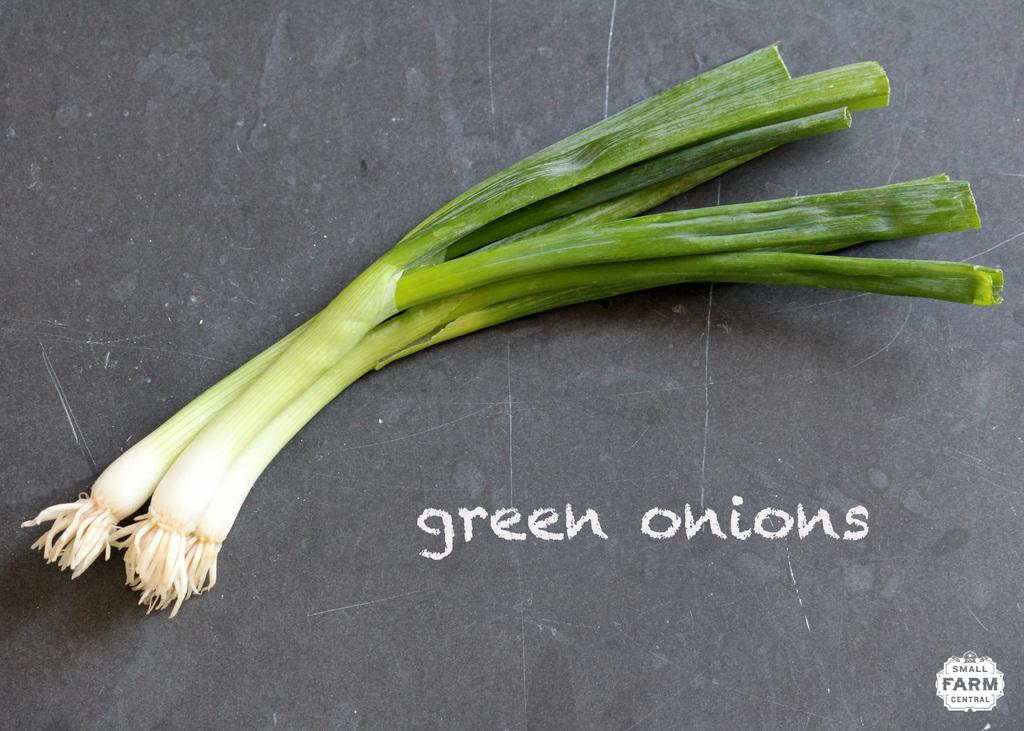What type of vegetables are in the image? There are spring onions in the image. What colors can be seen on the spring onions? The spring onions have white and green colors. What color is the background of the image? The background of the image is grey. What text is visible in the image? The text "green onions" is visible in the image. Can you recall the memory of the cow grazing in the field near the spring onions in the image? There is no cow or field present in the image; it only features spring onions and the text "green onions." 